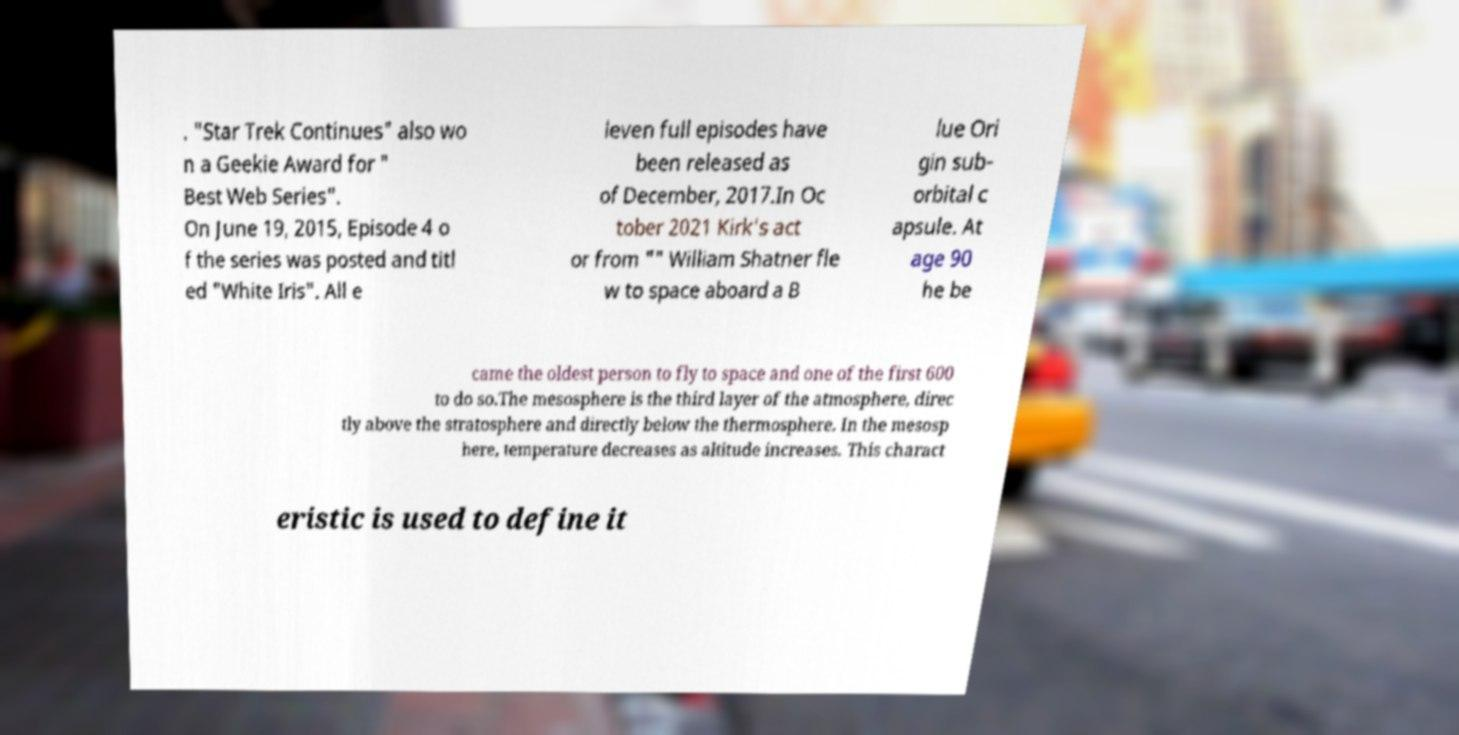Can you accurately transcribe the text from the provided image for me? . "Star Trek Continues" also wo n a Geekie Award for " Best Web Series". On June 19, 2015, Episode 4 o f the series was posted and titl ed "White Iris". All e leven full episodes have been released as of December, 2017.In Oc tober 2021 Kirk's act or from "" William Shatner fle w to space aboard a B lue Ori gin sub- orbital c apsule. At age 90 he be came the oldest person to fly to space and one of the first 600 to do so.The mesosphere is the third layer of the atmosphere, direc tly above the stratosphere and directly below the thermosphere. In the mesosp here, temperature decreases as altitude increases. This charact eristic is used to define it 